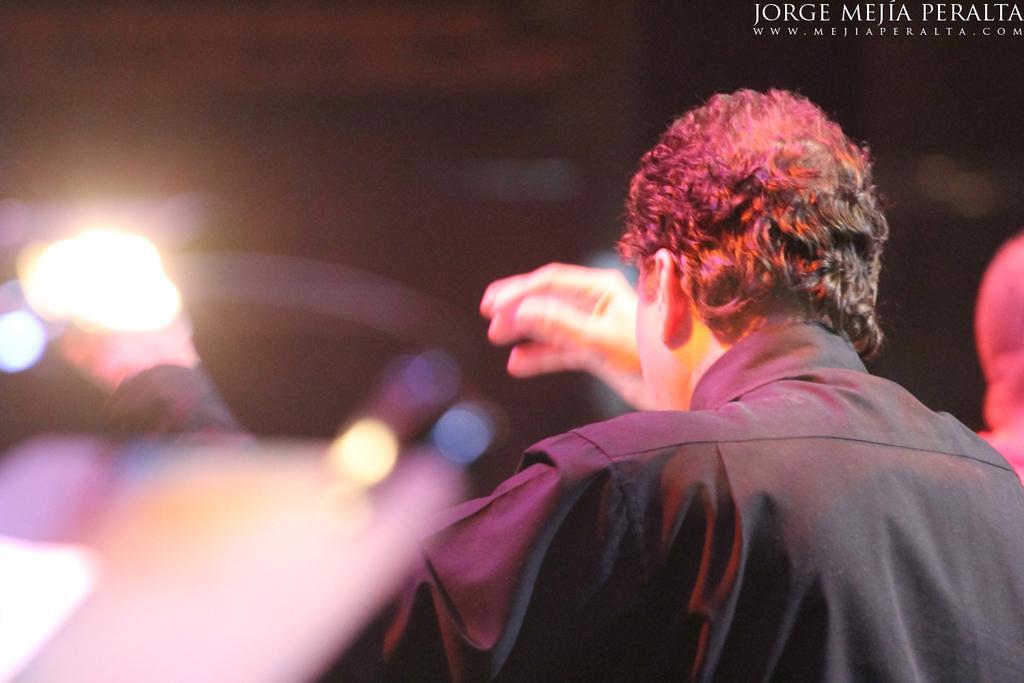Could you give a brief overview of what you see in this image? A man is wearing black color shirt. 